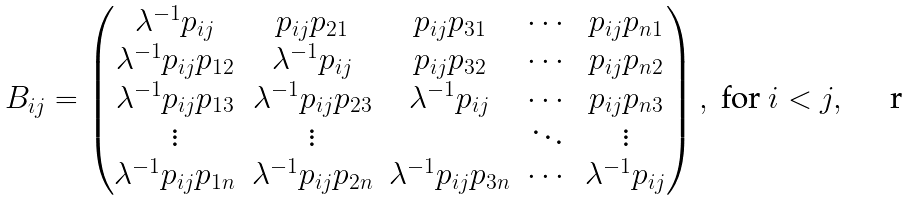<formula> <loc_0><loc_0><loc_500><loc_500>B _ { i j } = \begin{pmatrix} \lambda ^ { - 1 } p _ { i j } & p _ { i j } p _ { 2 1 } & p _ { i j } p _ { 3 1 } & \cdots & p _ { i j } p _ { n 1 } \\ \lambda ^ { - 1 } p _ { i j } p _ { 1 2 } & \lambda ^ { - 1 } p _ { i j } & p _ { i j } p _ { 3 2 } & \cdots & p _ { i j } p _ { n 2 } \\ \lambda ^ { - 1 } p _ { i j } p _ { 1 3 } & \lambda ^ { - 1 } p _ { i j } p _ { 2 3 } & \lambda ^ { - 1 } p _ { i j } & \cdots & p _ { i j } p _ { n 3 } \\ \vdots & \vdots & & \ddots & \vdots \\ \lambda ^ { - 1 } p _ { i j } p _ { 1 n } & \lambda ^ { - 1 } p _ { i j } p _ { 2 n } & \lambda ^ { - 1 } p _ { i j } p _ { 3 n } & \cdots & \lambda ^ { - 1 } p _ { i j } \end{pmatrix} , \text { for } i < j , \\</formula> 